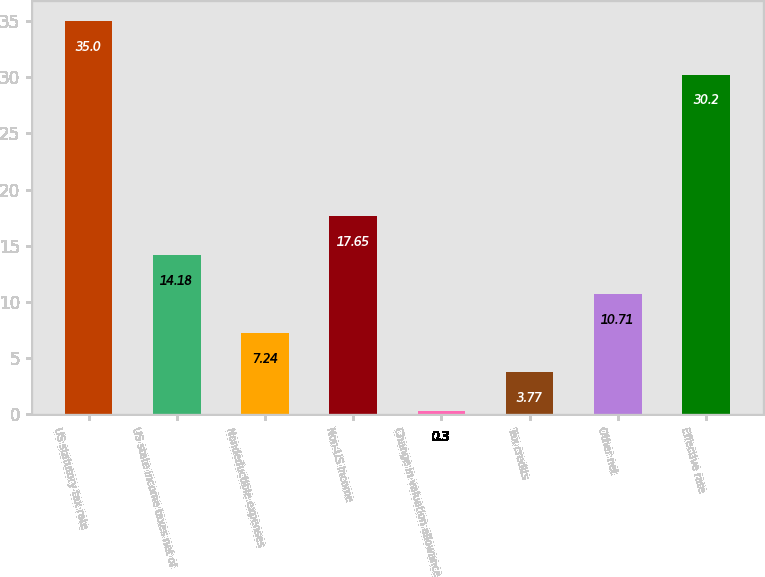<chart> <loc_0><loc_0><loc_500><loc_500><bar_chart><fcel>US statutory tax rate<fcel>US state income taxes net of<fcel>Nondeductible expenses<fcel>Non-US income<fcel>Change in valuation allowance<fcel>Tax credits<fcel>Other net<fcel>Effective rate<nl><fcel>35<fcel>14.18<fcel>7.24<fcel>17.65<fcel>0.3<fcel>3.77<fcel>10.71<fcel>30.2<nl></chart> 